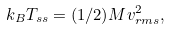<formula> <loc_0><loc_0><loc_500><loc_500>k _ { B } T _ { s s } = ( 1 / 2 ) M v _ { r m s } ^ { 2 } ,</formula> 